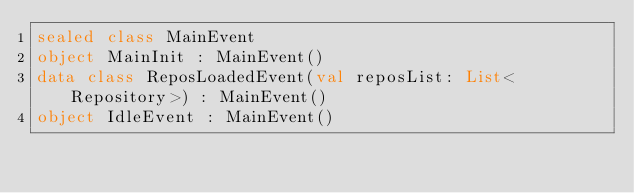Convert code to text. <code><loc_0><loc_0><loc_500><loc_500><_Kotlin_>sealed class MainEvent
object MainInit : MainEvent()
data class ReposLoadedEvent(val reposList: List<Repository>) : MainEvent()
object IdleEvent : MainEvent()</code> 